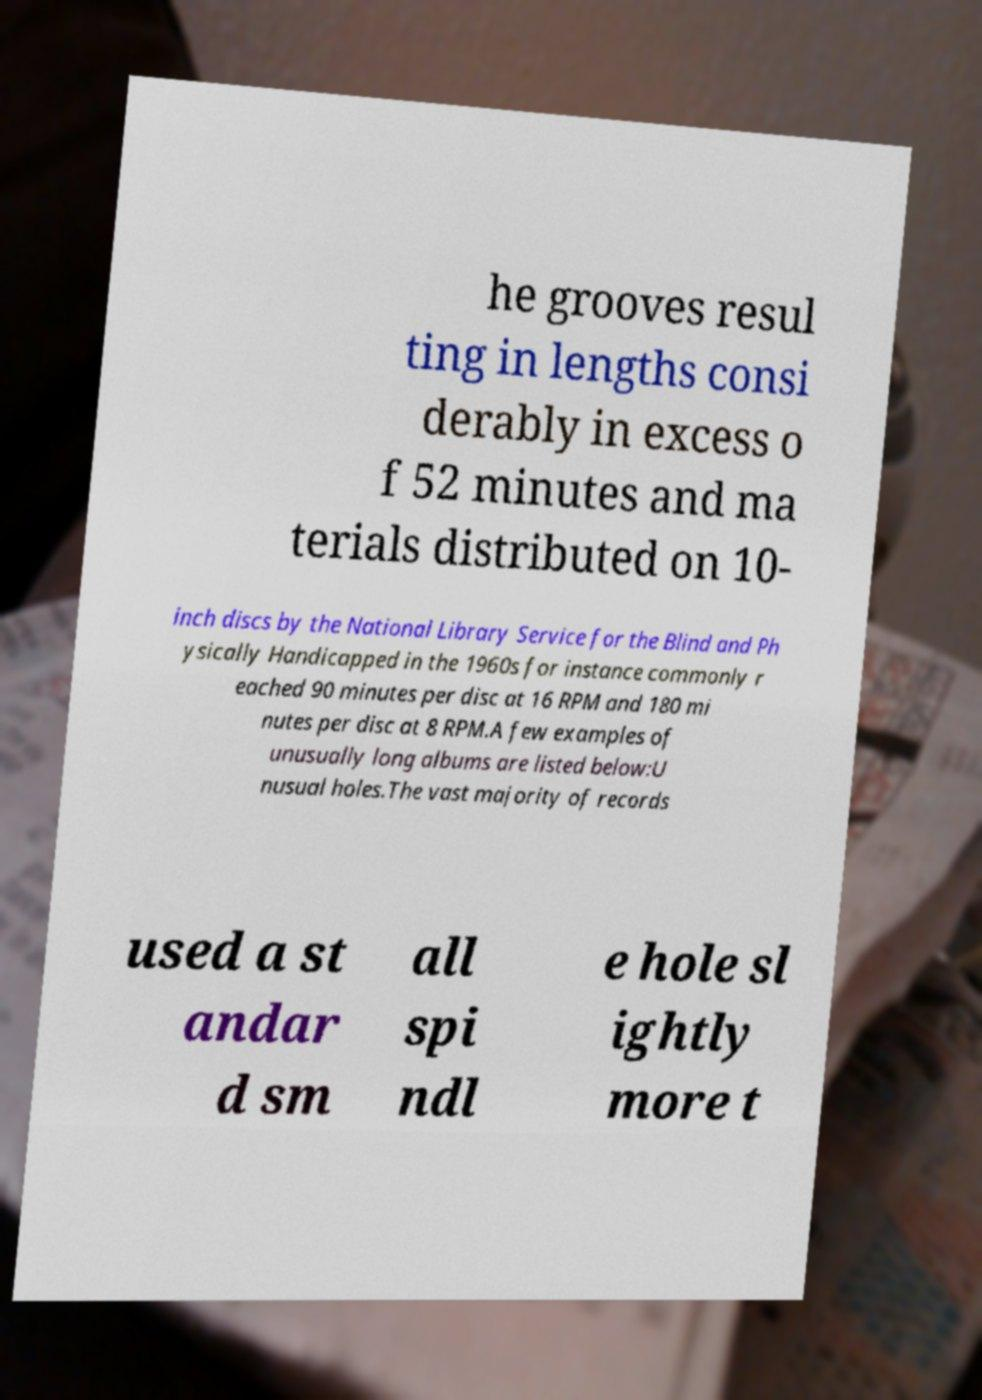Could you extract and type out the text from this image? he grooves resul ting in lengths consi derably in excess o f 52 minutes and ma terials distributed on 10- inch discs by the National Library Service for the Blind and Ph ysically Handicapped in the 1960s for instance commonly r eached 90 minutes per disc at 16 RPM and 180 mi nutes per disc at 8 RPM.A few examples of unusually long albums are listed below:U nusual holes.The vast majority of records used a st andar d sm all spi ndl e hole sl ightly more t 